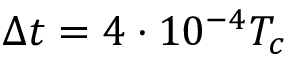<formula> <loc_0><loc_0><loc_500><loc_500>\Delta t = 4 \cdot 1 0 ^ { - 4 } T _ { c }</formula> 